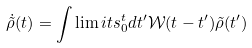Convert formula to latex. <formula><loc_0><loc_0><loc_500><loc_500>\dot { \tilde { \rho } } ( t ) = \int \lim i t s _ { 0 } ^ { t } d t ^ { \prime } \mathcal { W } ( t - t ^ { \prime } ) \tilde { \rho } ( t ^ { \prime } )</formula> 